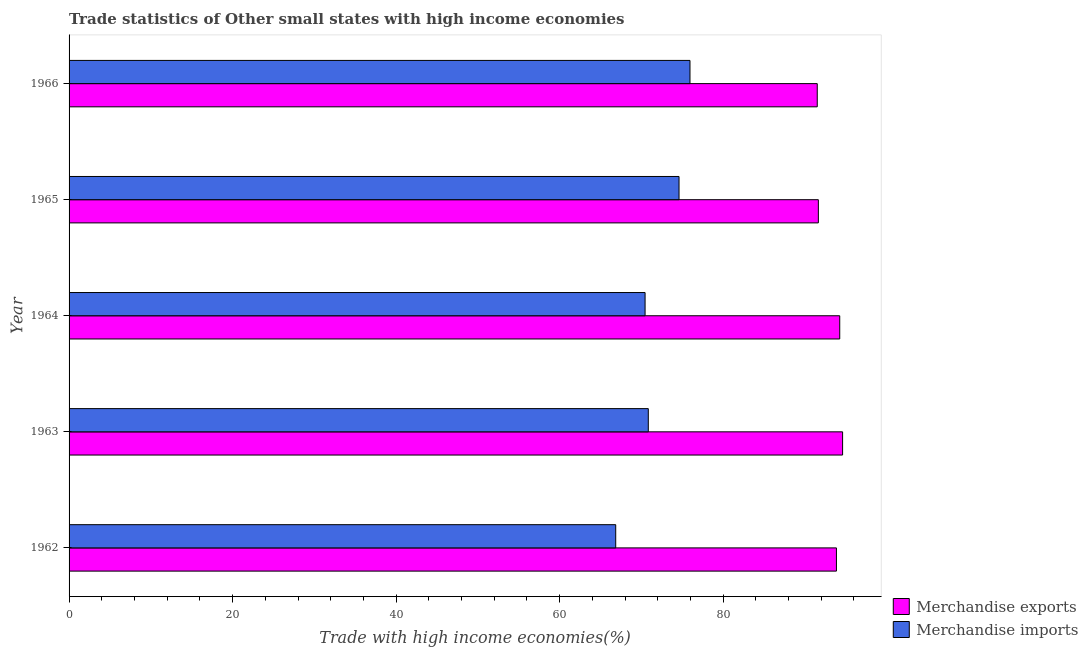How many different coloured bars are there?
Your answer should be compact. 2. Are the number of bars on each tick of the Y-axis equal?
Your answer should be compact. Yes. How many bars are there on the 1st tick from the top?
Make the answer very short. 2. What is the label of the 1st group of bars from the top?
Keep it short and to the point. 1966. What is the merchandise exports in 1965?
Your answer should be compact. 91.64. Across all years, what is the maximum merchandise exports?
Provide a short and direct response. 94.61. Across all years, what is the minimum merchandise imports?
Ensure brevity in your answer.  66.86. In which year was the merchandise imports maximum?
Your answer should be compact. 1966. What is the total merchandise imports in the graph?
Provide a short and direct response. 358.7. What is the difference between the merchandise exports in 1962 and that in 1965?
Your answer should be very brief. 2.21. What is the difference between the merchandise exports in 1962 and the merchandise imports in 1966?
Provide a short and direct response. 17.91. What is the average merchandise imports per year?
Offer a terse response. 71.74. In the year 1963, what is the difference between the merchandise exports and merchandise imports?
Provide a succinct answer. 23.77. In how many years, is the merchandise imports greater than 92 %?
Your response must be concise. 0. What is the ratio of the merchandise imports in 1963 to that in 1964?
Offer a very short reply. 1.01. Is the difference between the merchandise imports in 1965 and 1966 greater than the difference between the merchandise exports in 1965 and 1966?
Provide a succinct answer. No. What is the difference between the highest and the second highest merchandise imports?
Your answer should be compact. 1.34. What does the 2nd bar from the top in 1962 represents?
Make the answer very short. Merchandise exports. How many bars are there?
Ensure brevity in your answer.  10. How many years are there in the graph?
Offer a terse response. 5. Are the values on the major ticks of X-axis written in scientific E-notation?
Make the answer very short. No. Does the graph contain grids?
Make the answer very short. No. Where does the legend appear in the graph?
Make the answer very short. Bottom right. How many legend labels are there?
Provide a short and direct response. 2. How are the legend labels stacked?
Ensure brevity in your answer.  Vertical. What is the title of the graph?
Provide a short and direct response. Trade statistics of Other small states with high income economies. Does "Not attending school" appear as one of the legend labels in the graph?
Ensure brevity in your answer.  No. What is the label or title of the X-axis?
Your response must be concise. Trade with high income economies(%). What is the label or title of the Y-axis?
Offer a very short reply. Year. What is the Trade with high income economies(%) in Merchandise exports in 1962?
Ensure brevity in your answer.  93.86. What is the Trade with high income economies(%) in Merchandise imports in 1962?
Your answer should be compact. 66.86. What is the Trade with high income economies(%) of Merchandise exports in 1963?
Make the answer very short. 94.61. What is the Trade with high income economies(%) in Merchandise imports in 1963?
Offer a very short reply. 70.84. What is the Trade with high income economies(%) in Merchandise exports in 1964?
Provide a succinct answer. 94.26. What is the Trade with high income economies(%) of Merchandise imports in 1964?
Your answer should be very brief. 70.45. What is the Trade with high income economies(%) of Merchandise exports in 1965?
Your response must be concise. 91.64. What is the Trade with high income economies(%) of Merchandise imports in 1965?
Your answer should be compact. 74.6. What is the Trade with high income economies(%) of Merchandise exports in 1966?
Your answer should be very brief. 91.51. What is the Trade with high income economies(%) of Merchandise imports in 1966?
Provide a short and direct response. 75.94. Across all years, what is the maximum Trade with high income economies(%) in Merchandise exports?
Your answer should be very brief. 94.61. Across all years, what is the maximum Trade with high income economies(%) of Merchandise imports?
Your answer should be very brief. 75.94. Across all years, what is the minimum Trade with high income economies(%) in Merchandise exports?
Make the answer very short. 91.51. Across all years, what is the minimum Trade with high income economies(%) in Merchandise imports?
Offer a very short reply. 66.86. What is the total Trade with high income economies(%) in Merchandise exports in the graph?
Keep it short and to the point. 465.87. What is the total Trade with high income economies(%) in Merchandise imports in the graph?
Ensure brevity in your answer.  358.7. What is the difference between the Trade with high income economies(%) of Merchandise exports in 1962 and that in 1963?
Provide a short and direct response. -0.75. What is the difference between the Trade with high income economies(%) of Merchandise imports in 1962 and that in 1963?
Ensure brevity in your answer.  -3.98. What is the difference between the Trade with high income economies(%) in Merchandise exports in 1962 and that in 1964?
Your response must be concise. -0.4. What is the difference between the Trade with high income economies(%) in Merchandise imports in 1962 and that in 1964?
Provide a succinct answer. -3.59. What is the difference between the Trade with high income economies(%) in Merchandise exports in 1962 and that in 1965?
Provide a short and direct response. 2.21. What is the difference between the Trade with high income economies(%) in Merchandise imports in 1962 and that in 1965?
Make the answer very short. -7.74. What is the difference between the Trade with high income economies(%) of Merchandise exports in 1962 and that in 1966?
Your answer should be very brief. 2.35. What is the difference between the Trade with high income economies(%) of Merchandise imports in 1962 and that in 1966?
Your answer should be compact. -9.08. What is the difference between the Trade with high income economies(%) of Merchandise exports in 1963 and that in 1964?
Ensure brevity in your answer.  0.35. What is the difference between the Trade with high income economies(%) of Merchandise imports in 1963 and that in 1964?
Give a very brief answer. 0.39. What is the difference between the Trade with high income economies(%) in Merchandise exports in 1963 and that in 1965?
Give a very brief answer. 2.96. What is the difference between the Trade with high income economies(%) in Merchandise imports in 1963 and that in 1965?
Give a very brief answer. -3.76. What is the difference between the Trade with high income economies(%) of Merchandise exports in 1963 and that in 1966?
Offer a very short reply. 3.1. What is the difference between the Trade with high income economies(%) of Merchandise imports in 1963 and that in 1966?
Keep it short and to the point. -5.1. What is the difference between the Trade with high income economies(%) in Merchandise exports in 1964 and that in 1965?
Keep it short and to the point. 2.61. What is the difference between the Trade with high income economies(%) in Merchandise imports in 1964 and that in 1965?
Your answer should be compact. -4.15. What is the difference between the Trade with high income economies(%) in Merchandise exports in 1964 and that in 1966?
Your answer should be very brief. 2.75. What is the difference between the Trade with high income economies(%) of Merchandise imports in 1964 and that in 1966?
Your answer should be very brief. -5.49. What is the difference between the Trade with high income economies(%) of Merchandise exports in 1965 and that in 1966?
Your response must be concise. 0.14. What is the difference between the Trade with high income economies(%) in Merchandise imports in 1965 and that in 1966?
Provide a succinct answer. -1.34. What is the difference between the Trade with high income economies(%) in Merchandise exports in 1962 and the Trade with high income economies(%) in Merchandise imports in 1963?
Ensure brevity in your answer.  23.01. What is the difference between the Trade with high income economies(%) in Merchandise exports in 1962 and the Trade with high income economies(%) in Merchandise imports in 1964?
Your answer should be compact. 23.4. What is the difference between the Trade with high income economies(%) of Merchandise exports in 1962 and the Trade with high income economies(%) of Merchandise imports in 1965?
Provide a short and direct response. 19.25. What is the difference between the Trade with high income economies(%) in Merchandise exports in 1962 and the Trade with high income economies(%) in Merchandise imports in 1966?
Provide a succinct answer. 17.91. What is the difference between the Trade with high income economies(%) in Merchandise exports in 1963 and the Trade with high income economies(%) in Merchandise imports in 1964?
Provide a short and direct response. 24.16. What is the difference between the Trade with high income economies(%) in Merchandise exports in 1963 and the Trade with high income economies(%) in Merchandise imports in 1965?
Your response must be concise. 20.01. What is the difference between the Trade with high income economies(%) of Merchandise exports in 1963 and the Trade with high income economies(%) of Merchandise imports in 1966?
Your answer should be very brief. 18.67. What is the difference between the Trade with high income economies(%) of Merchandise exports in 1964 and the Trade with high income economies(%) of Merchandise imports in 1965?
Offer a very short reply. 19.66. What is the difference between the Trade with high income economies(%) of Merchandise exports in 1964 and the Trade with high income economies(%) of Merchandise imports in 1966?
Ensure brevity in your answer.  18.32. What is the difference between the Trade with high income economies(%) in Merchandise exports in 1965 and the Trade with high income economies(%) in Merchandise imports in 1966?
Give a very brief answer. 15.7. What is the average Trade with high income economies(%) in Merchandise exports per year?
Provide a succinct answer. 93.17. What is the average Trade with high income economies(%) of Merchandise imports per year?
Your answer should be compact. 71.74. In the year 1962, what is the difference between the Trade with high income economies(%) in Merchandise exports and Trade with high income economies(%) in Merchandise imports?
Your answer should be very brief. 27. In the year 1963, what is the difference between the Trade with high income economies(%) of Merchandise exports and Trade with high income economies(%) of Merchandise imports?
Your answer should be very brief. 23.77. In the year 1964, what is the difference between the Trade with high income economies(%) of Merchandise exports and Trade with high income economies(%) of Merchandise imports?
Give a very brief answer. 23.81. In the year 1965, what is the difference between the Trade with high income economies(%) in Merchandise exports and Trade with high income economies(%) in Merchandise imports?
Provide a succinct answer. 17.04. In the year 1966, what is the difference between the Trade with high income economies(%) in Merchandise exports and Trade with high income economies(%) in Merchandise imports?
Keep it short and to the point. 15.56. What is the ratio of the Trade with high income economies(%) of Merchandise exports in 1962 to that in 1963?
Provide a short and direct response. 0.99. What is the ratio of the Trade with high income economies(%) of Merchandise imports in 1962 to that in 1963?
Your response must be concise. 0.94. What is the ratio of the Trade with high income economies(%) of Merchandise exports in 1962 to that in 1964?
Make the answer very short. 1. What is the ratio of the Trade with high income economies(%) in Merchandise imports in 1962 to that in 1964?
Your answer should be very brief. 0.95. What is the ratio of the Trade with high income economies(%) in Merchandise exports in 1962 to that in 1965?
Provide a succinct answer. 1.02. What is the ratio of the Trade with high income economies(%) in Merchandise imports in 1962 to that in 1965?
Provide a short and direct response. 0.9. What is the ratio of the Trade with high income economies(%) in Merchandise exports in 1962 to that in 1966?
Provide a short and direct response. 1.03. What is the ratio of the Trade with high income economies(%) of Merchandise imports in 1962 to that in 1966?
Provide a succinct answer. 0.88. What is the ratio of the Trade with high income economies(%) in Merchandise exports in 1963 to that in 1964?
Give a very brief answer. 1. What is the ratio of the Trade with high income economies(%) of Merchandise imports in 1963 to that in 1964?
Your answer should be very brief. 1.01. What is the ratio of the Trade with high income economies(%) in Merchandise exports in 1963 to that in 1965?
Make the answer very short. 1.03. What is the ratio of the Trade with high income economies(%) in Merchandise imports in 1963 to that in 1965?
Make the answer very short. 0.95. What is the ratio of the Trade with high income economies(%) in Merchandise exports in 1963 to that in 1966?
Provide a succinct answer. 1.03. What is the ratio of the Trade with high income economies(%) in Merchandise imports in 1963 to that in 1966?
Provide a succinct answer. 0.93. What is the ratio of the Trade with high income economies(%) in Merchandise exports in 1964 to that in 1965?
Provide a succinct answer. 1.03. What is the ratio of the Trade with high income economies(%) in Merchandise imports in 1964 to that in 1965?
Give a very brief answer. 0.94. What is the ratio of the Trade with high income economies(%) of Merchandise exports in 1964 to that in 1966?
Make the answer very short. 1.03. What is the ratio of the Trade with high income economies(%) in Merchandise imports in 1964 to that in 1966?
Offer a terse response. 0.93. What is the ratio of the Trade with high income economies(%) of Merchandise imports in 1965 to that in 1966?
Keep it short and to the point. 0.98. What is the difference between the highest and the second highest Trade with high income economies(%) of Merchandise exports?
Offer a very short reply. 0.35. What is the difference between the highest and the second highest Trade with high income economies(%) of Merchandise imports?
Provide a succinct answer. 1.34. What is the difference between the highest and the lowest Trade with high income economies(%) of Merchandise exports?
Ensure brevity in your answer.  3.1. What is the difference between the highest and the lowest Trade with high income economies(%) in Merchandise imports?
Your answer should be compact. 9.08. 